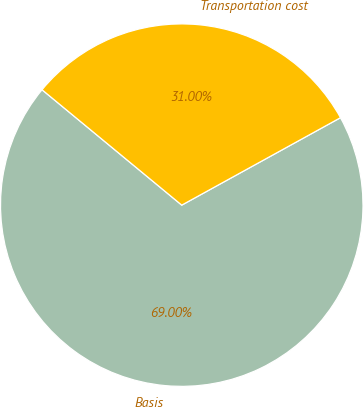Convert chart. <chart><loc_0><loc_0><loc_500><loc_500><pie_chart><fcel>Basis<fcel>Transportation cost<nl><fcel>69.0%<fcel>31.0%<nl></chart> 